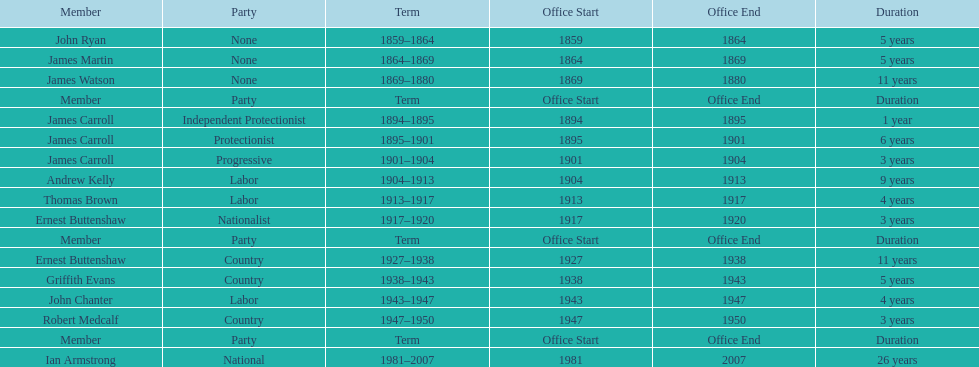How long did ian armstrong serve? 26 years. 